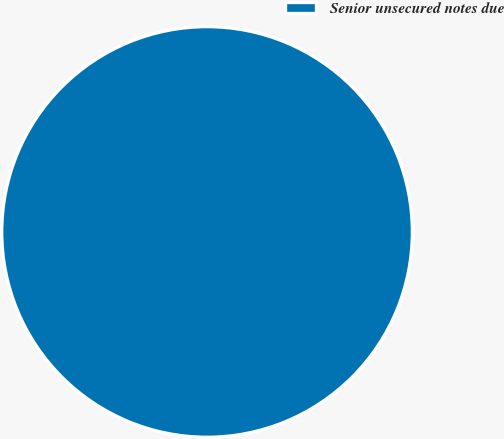<chart> <loc_0><loc_0><loc_500><loc_500><pie_chart><fcel>Senior unsecured notes due<nl><fcel>100.0%<nl></chart> 